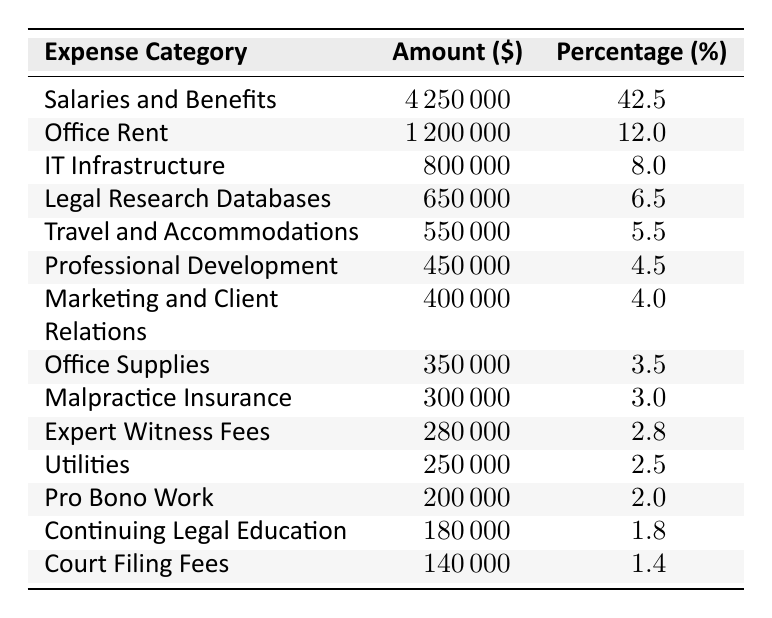What is the highest expense category? The highest expense category listed in the table is "Salaries and Benefits," with an amount of $4,250,000.
Answer: Salaries and Benefits What percentage of total expenses is spent on Office Rent? Office Rent accounts for 12.0% of the total expenses, as shown in the table.
Answer: 12.0% How much did the firm spend on IT Infrastructure? The firm spent $800,000 on IT Infrastructure, which is clearly stated in the corresponding row.
Answer: $800,000 What is the total amount spent on Travel and Accommodations and Marketing and Client Relations combined? The total for both categories is calculated as $550,000 (Travel and Accommodations) + $400,000 (Marketing and Client Relations) = $950,000.
Answer: $950,000 Is Pro Bono Work more expensive than Court Filing Fees? Yes, Pro Bono Work costs $200,000 while Court Filing Fees cost $140,000, making Pro Bono Work more expensive.
Answer: Yes What percentage of expenses is allocated to Professional Development relative to the total expenses? Professional Development is allocated 4.5% of the total expenses, as indicated in that row of the table.
Answer: 4.5% What is the difference in amount between Legal Research Databases and Expert Witness Fees? The difference is calculated as $650,000 (Legal Research Databases) - $280,000 (Expert Witness Fees) = $370,000.
Answer: $370,000 What would be the combined expenses of the three categories with the lowest costs? The three lowest costs are Continuing Legal Education ($180,000), Court Filing Fees ($140,000), and Utilities ($250,000). Their combined expenses amount to $180,000 + $140,000 + $250,000 = $570,000.
Answer: $570,000 How much more is spent on Malpractice Insurance than on Utilities? Malpractice Insurance is $300,000 and Utilities is $250,000. The difference is $300,000 - $250,000 = $50,000.
Answer: $50,000 What fraction of the total expenses is spent on Marketing and Client Relations? The firm spends $400,000 on Marketing and Client Relations. To find the fraction, first calculate the total expenses ($4,250,000 + $1,200,000 + ... + $140,000) which equals $10,000,000. Thus, the fraction is $400,000/$10,000,000 = 0.04.
Answer: 0.04 